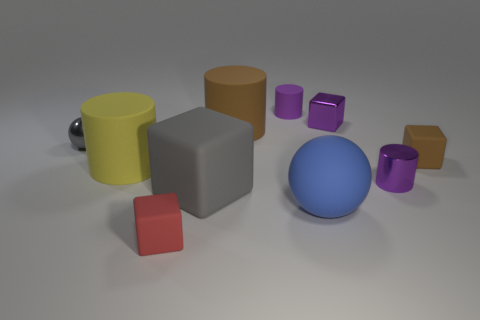What size is the shiny thing that is the same color as the large block?
Ensure brevity in your answer.  Small. Is there a big sphere that has the same color as the tiny rubber cylinder?
Provide a short and direct response. No. There is a red cube that is made of the same material as the big gray block; what size is it?
Your answer should be very brief. Small. Are the tiny brown object and the gray ball made of the same material?
Make the answer very short. No. What is the color of the big cylinder that is in front of the small sphere that is behind the large thing that is on the left side of the small red rubber thing?
Keep it short and to the point. Yellow. What shape is the yellow thing?
Keep it short and to the point. Cylinder. Does the tiny shiny block have the same color as the ball that is right of the purple matte cylinder?
Provide a short and direct response. No. Is the number of large gray cubes behind the purple rubber object the same as the number of red shiny blocks?
Ensure brevity in your answer.  Yes. What number of rubber cubes have the same size as the yellow rubber cylinder?
Your answer should be very brief. 1. The small matte object that is the same color as the metallic cylinder is what shape?
Keep it short and to the point. Cylinder. 